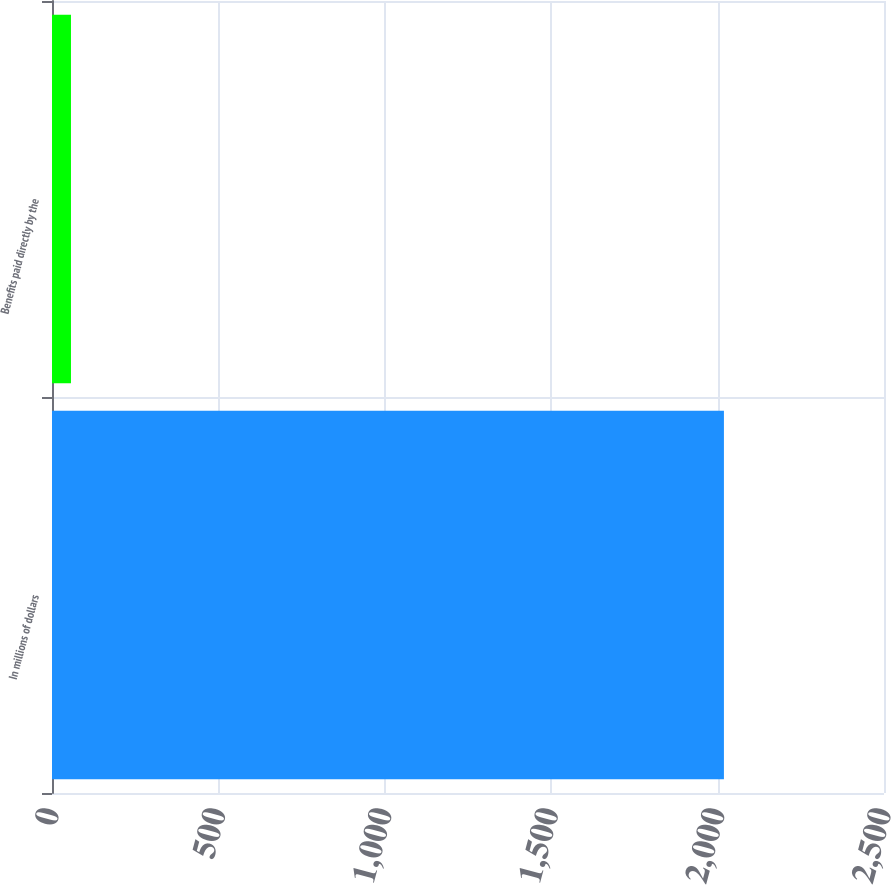Convert chart to OTSL. <chart><loc_0><loc_0><loc_500><loc_500><bar_chart><fcel>In millions of dollars<fcel>Benefits paid directly by the<nl><fcel>2019<fcel>57<nl></chart> 